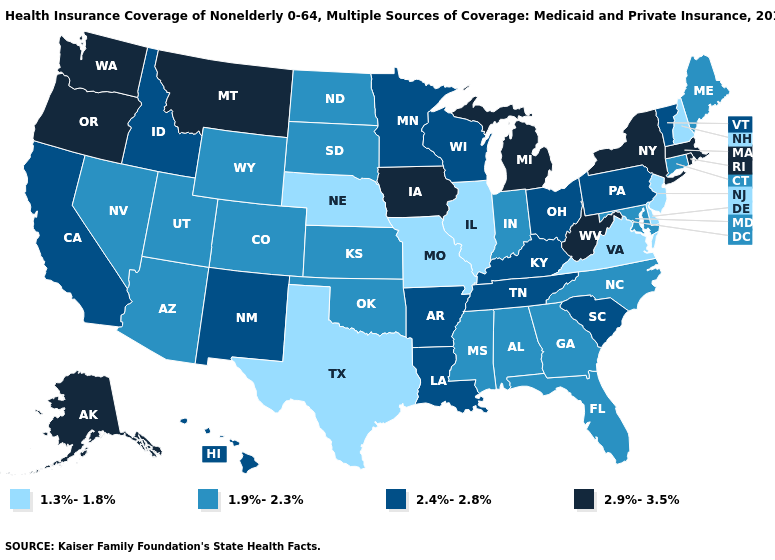What is the highest value in the USA?
Be succinct. 2.9%-3.5%. Name the states that have a value in the range 1.9%-2.3%?
Concise answer only. Alabama, Arizona, Colorado, Connecticut, Florida, Georgia, Indiana, Kansas, Maine, Maryland, Mississippi, Nevada, North Carolina, North Dakota, Oklahoma, South Dakota, Utah, Wyoming. Does South Dakota have the highest value in the USA?
Quick response, please. No. Which states have the lowest value in the South?
Be succinct. Delaware, Texas, Virginia. What is the value of Kentucky?
Quick response, please. 2.4%-2.8%. Does Maryland have a lower value than Illinois?
Answer briefly. No. What is the value of Ohio?
Concise answer only. 2.4%-2.8%. Name the states that have a value in the range 1.9%-2.3%?
Answer briefly. Alabama, Arizona, Colorado, Connecticut, Florida, Georgia, Indiana, Kansas, Maine, Maryland, Mississippi, Nevada, North Carolina, North Dakota, Oklahoma, South Dakota, Utah, Wyoming. Does Maryland have the same value as Arizona?
Be succinct. Yes. Is the legend a continuous bar?
Keep it brief. No. What is the value of Montana?
Give a very brief answer. 2.9%-3.5%. What is the lowest value in states that border Virginia?
Answer briefly. 1.9%-2.3%. What is the lowest value in the Northeast?
Quick response, please. 1.3%-1.8%. Name the states that have a value in the range 1.3%-1.8%?
Be succinct. Delaware, Illinois, Missouri, Nebraska, New Hampshire, New Jersey, Texas, Virginia. What is the highest value in the MidWest ?
Write a very short answer. 2.9%-3.5%. 